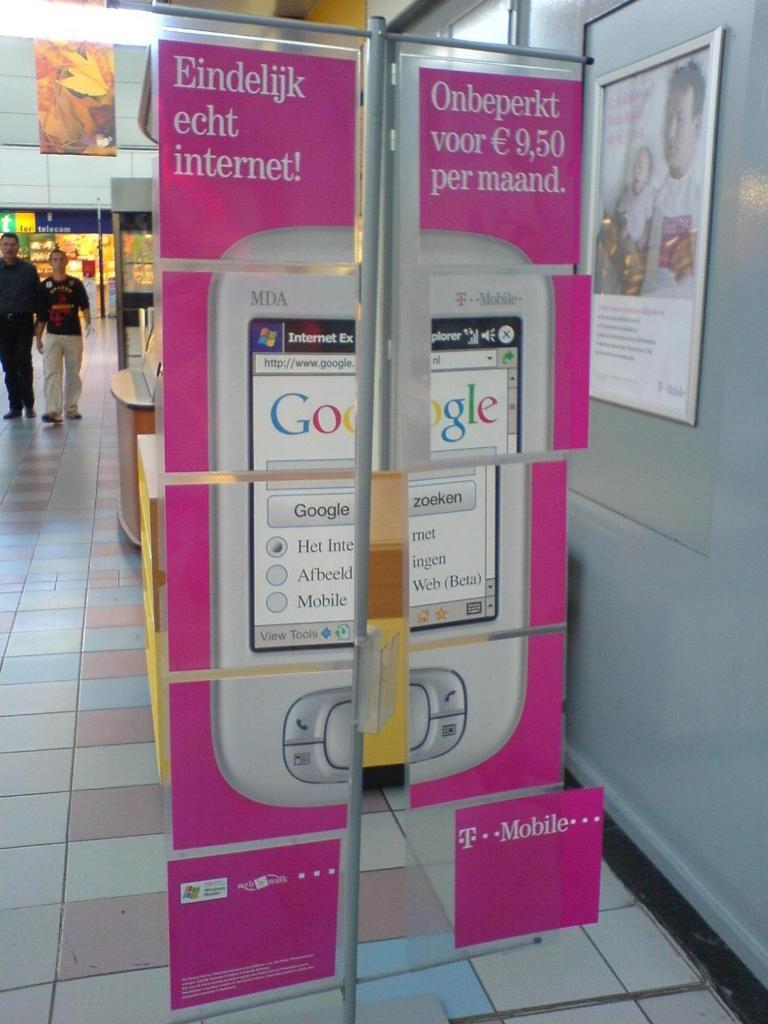<image>
Relay a brief, clear account of the picture shown. A T-Mobile banner hangs from grey metal bars advertising an MDA phone. 